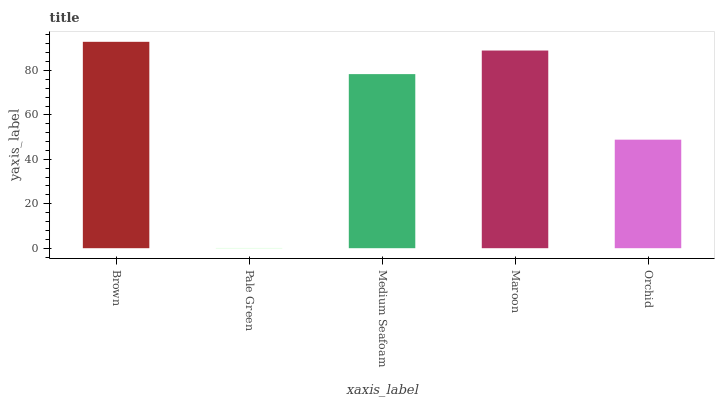Is Pale Green the minimum?
Answer yes or no. Yes. Is Brown the maximum?
Answer yes or no. Yes. Is Medium Seafoam the minimum?
Answer yes or no. No. Is Medium Seafoam the maximum?
Answer yes or no. No. Is Medium Seafoam greater than Pale Green?
Answer yes or no. Yes. Is Pale Green less than Medium Seafoam?
Answer yes or no. Yes. Is Pale Green greater than Medium Seafoam?
Answer yes or no. No. Is Medium Seafoam less than Pale Green?
Answer yes or no. No. Is Medium Seafoam the high median?
Answer yes or no. Yes. Is Medium Seafoam the low median?
Answer yes or no. Yes. Is Pale Green the high median?
Answer yes or no. No. Is Orchid the low median?
Answer yes or no. No. 